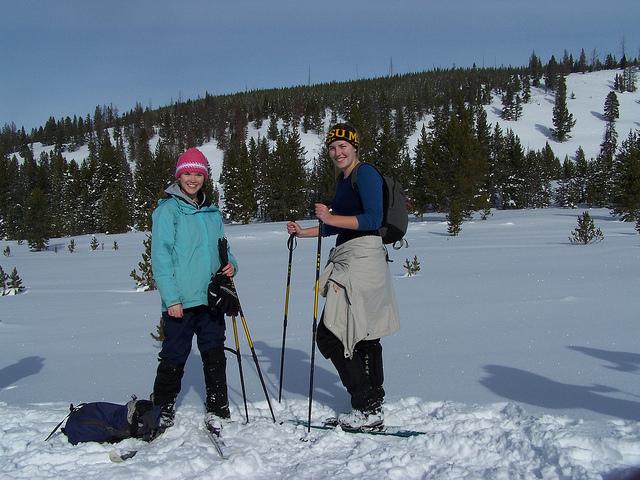Will anyone be snowboarding?
Keep it brief. No. Name object in front of lady?
Give a very brief answer. Backpack. What color are the ski poles the person on the right is holding?
Write a very short answer. Black and yellow. How many people are wearing eye protection?
Be succinct. 0. Have there been skiers on the same route before them?
Write a very short answer. Yes. Who is with the man?
Give a very brief answer. Woman. Are their shadows in front of the skiers?
Be succinct. No. Are they wearing glasses?
Answer briefly. No. What is covering the ground?
Short answer required. Snow. Is the snow deep?
Give a very brief answer. No. Where direction are the skiers looking?
Short answer required. Forward. Are both these skiers adults?
Quick response, please. Yes. What is in the snow?
Quick response, please. Trees. What color is the girl on the left's hat?
Short answer required. Pink. Is the mountain rocky?
Write a very short answer. No. Which two clothing items are not black?
Be succinct. Jackets. Which man has his skies facing a different way than the other men?
Write a very short answer. One on right. 